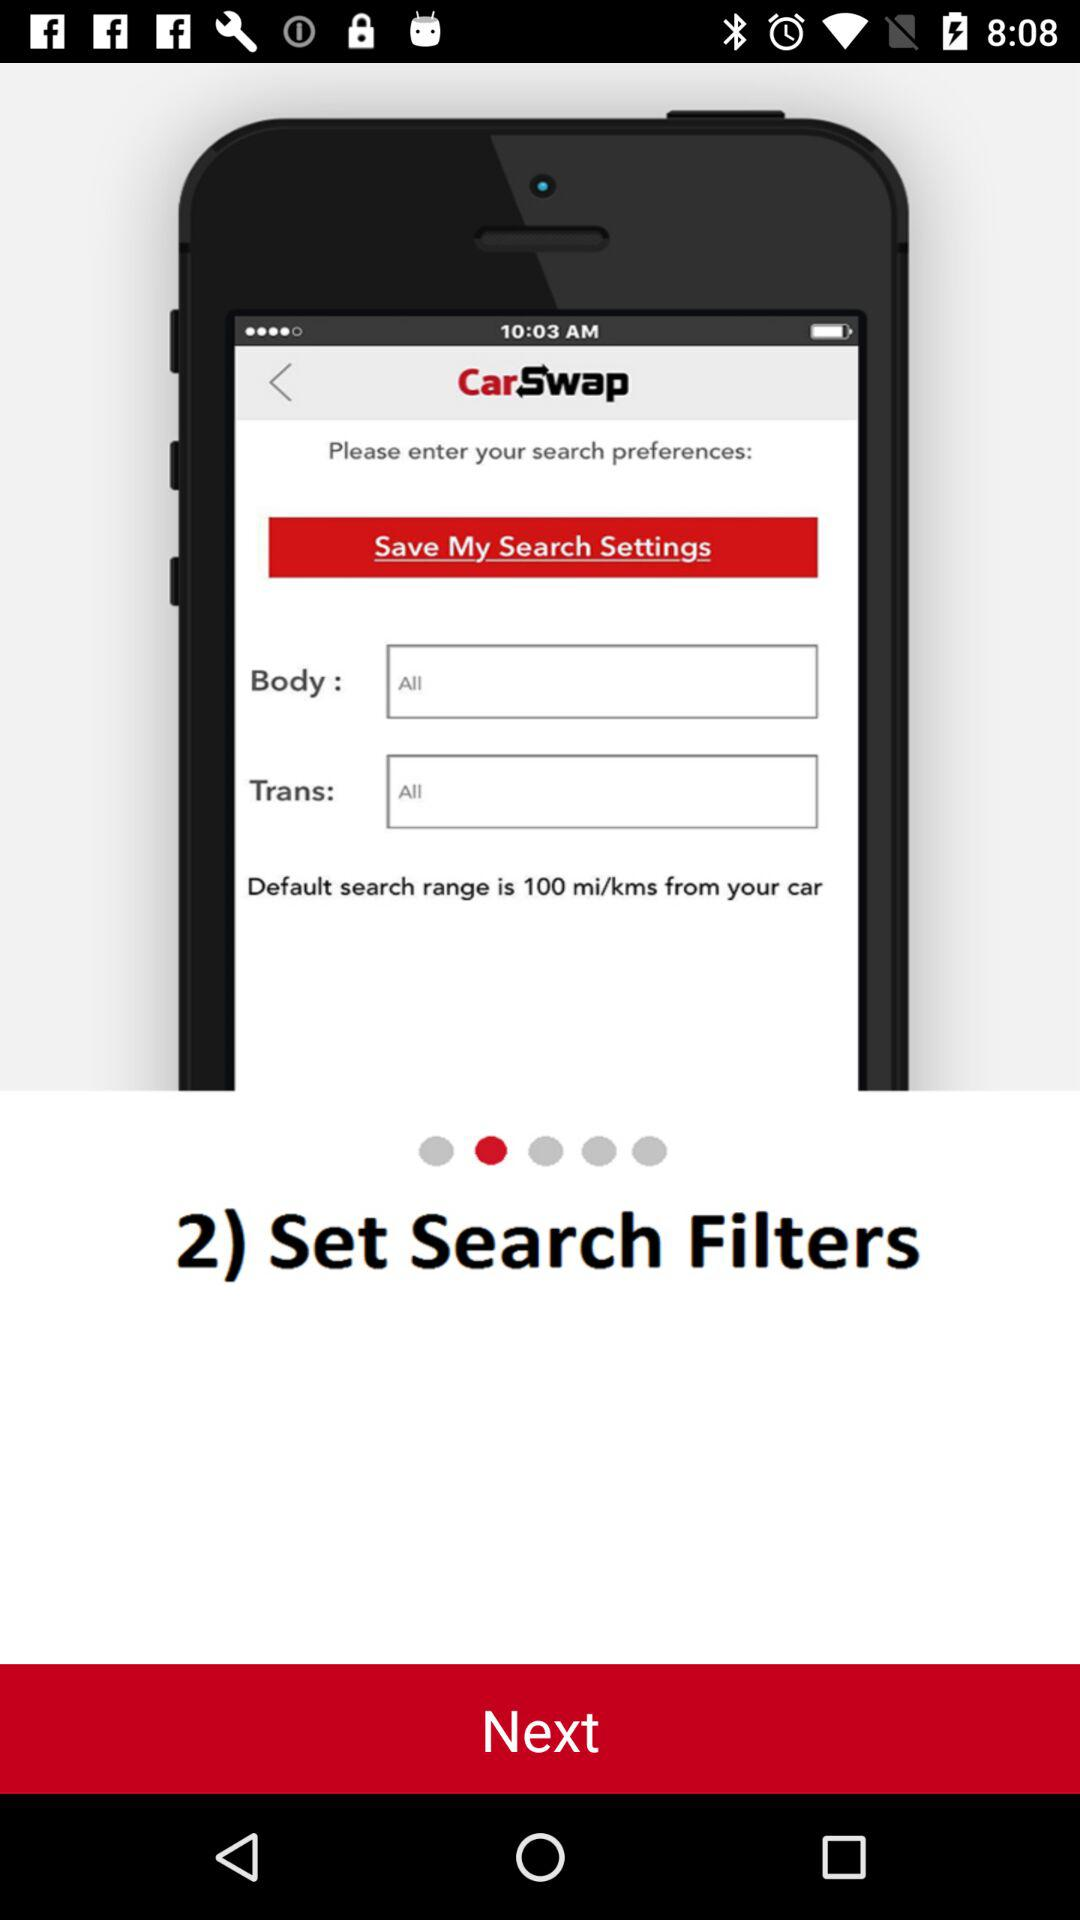How many more filters are there than pager indicators?
Answer the question using a single word or phrase. 1 